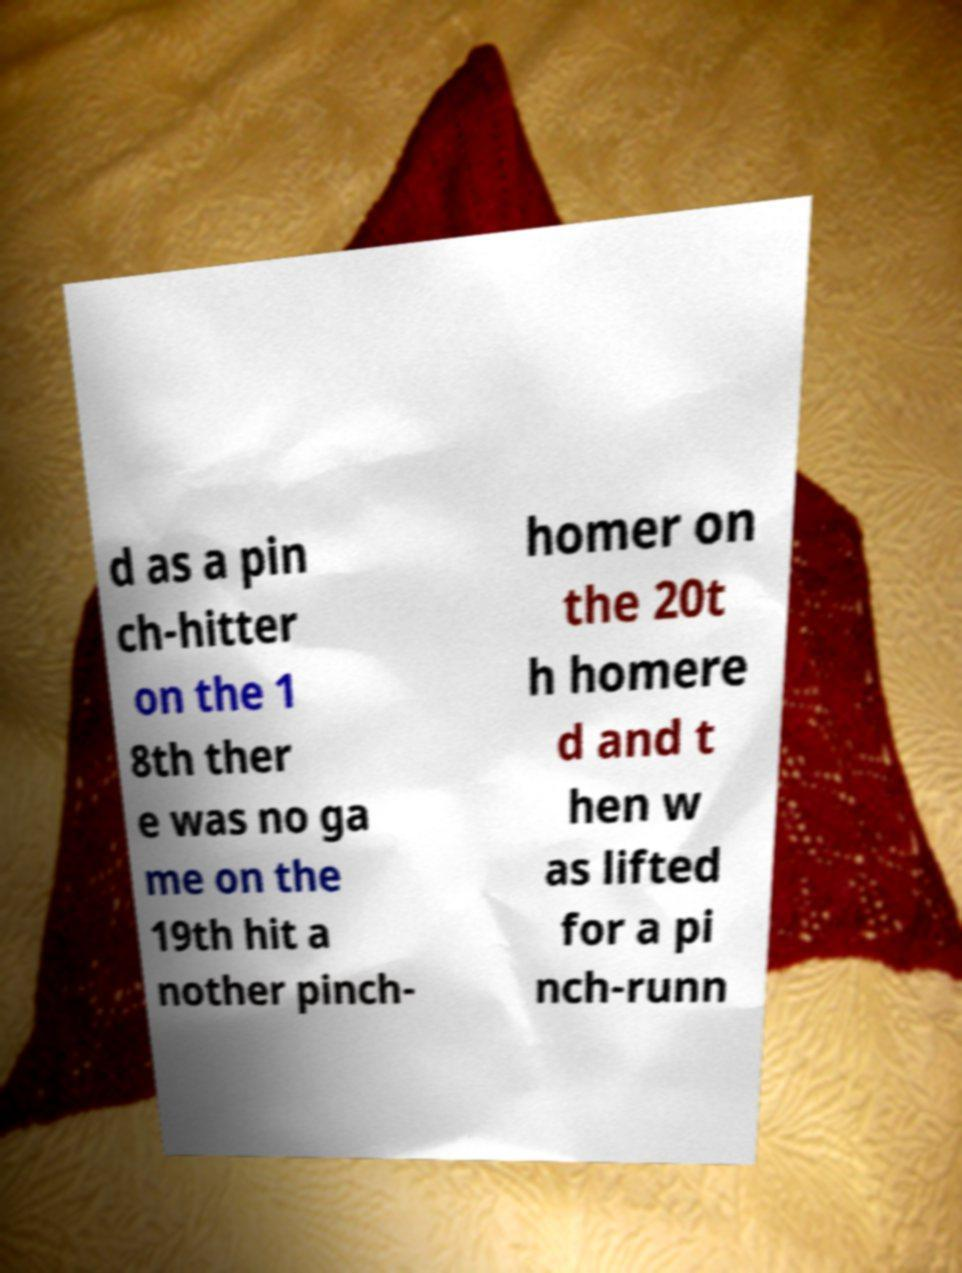Can you accurately transcribe the text from the provided image for me? d as a pin ch-hitter on the 1 8th ther e was no ga me on the 19th hit a nother pinch- homer on the 20t h homere d and t hen w as lifted for a pi nch-runn 